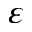Convert formula to latex. <formula><loc_0><loc_0><loc_500><loc_500>\varepsilon</formula> 